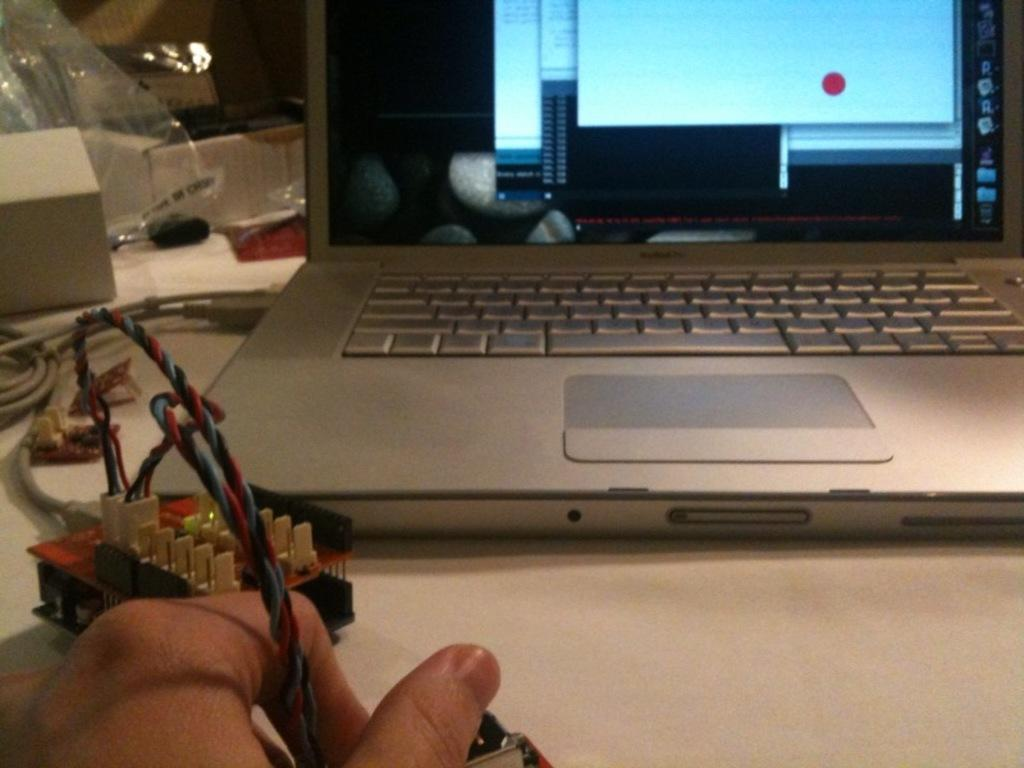What is the human hand doing in the image? The human hand is holding a wire in the image. Where is the hand located in the image? The hand is at the bottom of the image. What electronic device is visible in the image? There is a laptop in the image. What is the color of the surface on which the objects are placed? The surface is white in color. What role does the actor play in the army in the image? There is no actor or army present in the image; it features a human hand holding a wire and a laptop on a white surface. 